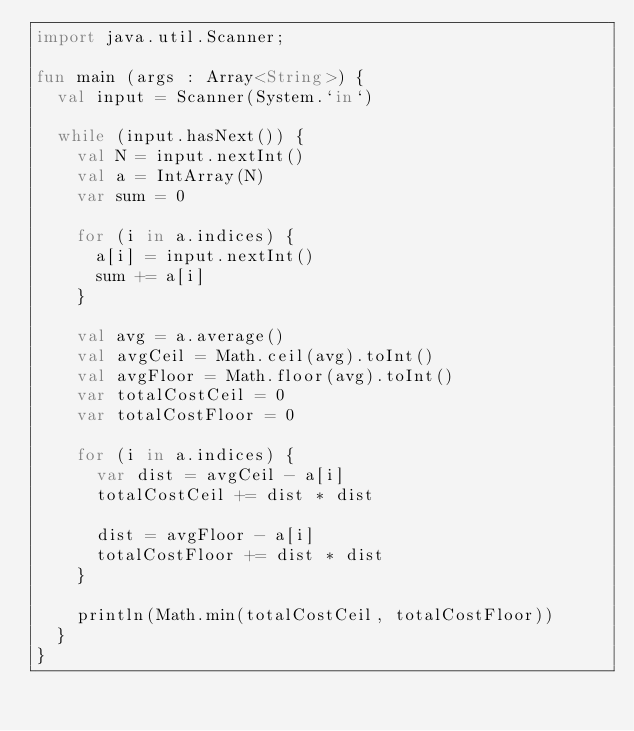Convert code to text. <code><loc_0><loc_0><loc_500><loc_500><_Kotlin_>import java.util.Scanner;

fun main (args : Array<String>) {
  val input = Scanner(System.`in`)
  
  while (input.hasNext()) {
    val N = input.nextInt()
    val a = IntArray(N)
    var sum = 0
    
    for (i in a.indices) {
      a[i] = input.nextInt()
      sum += a[i]
    }
    
    val avg = a.average()
    val avgCeil = Math.ceil(avg).toInt()
    val avgFloor = Math.floor(avg).toInt()
    var totalCostCeil = 0
    var totalCostFloor = 0
    
    for (i in a.indices) {
      var dist = avgCeil - a[i]
      totalCostCeil += dist * dist
      
      dist = avgFloor - a[i]
      totalCostFloor += dist * dist
    }
    
    println(Math.min(totalCostCeil, totalCostFloor))
  }
}</code> 